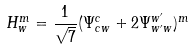<formula> <loc_0><loc_0><loc_500><loc_500>H ^ { m } _ { w } = \frac { 1 } { \sqrt { 7 } } ( \Psi ^ { c } _ { c w } + 2 \Psi ^ { w ^ { \prime } } _ { w ^ { \prime } w } ) ^ { m }</formula> 